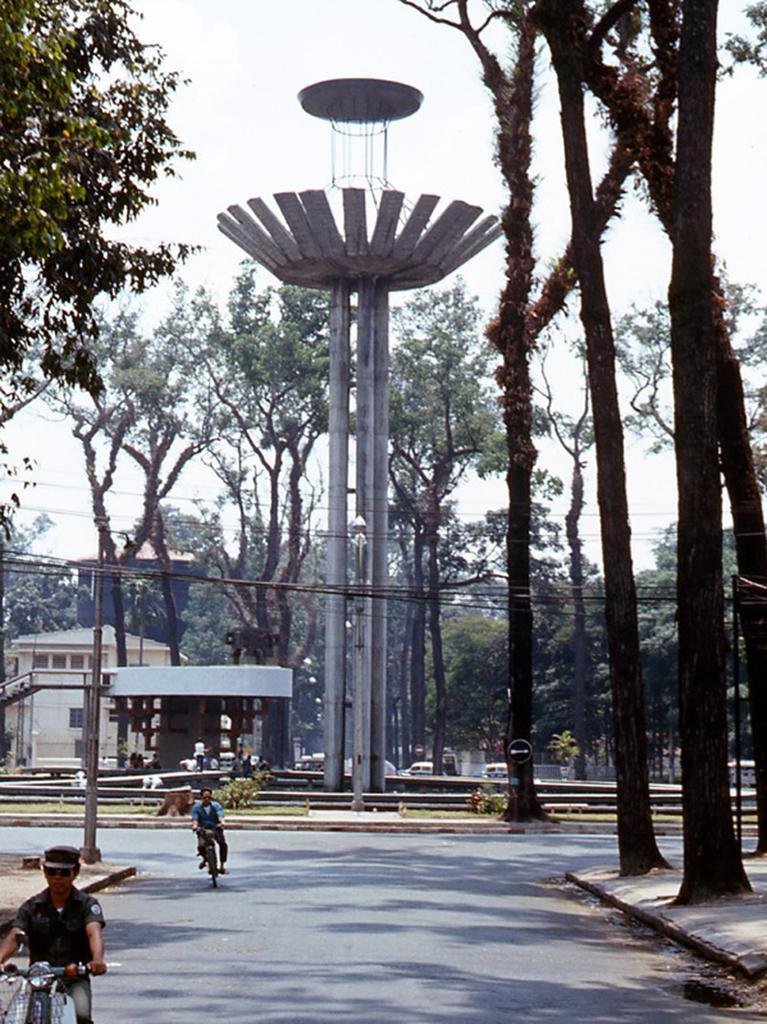In one or two sentences, can you explain what this image depicts? In this image I can see a road in the centre and on it I can see two persons are sitting on their vehicles. On the both sides of the road I can see number of trees, few poles and on the top side of the image I can see number of wires. In the background I can see number of trees, few more poles, few buildings and the sky. 